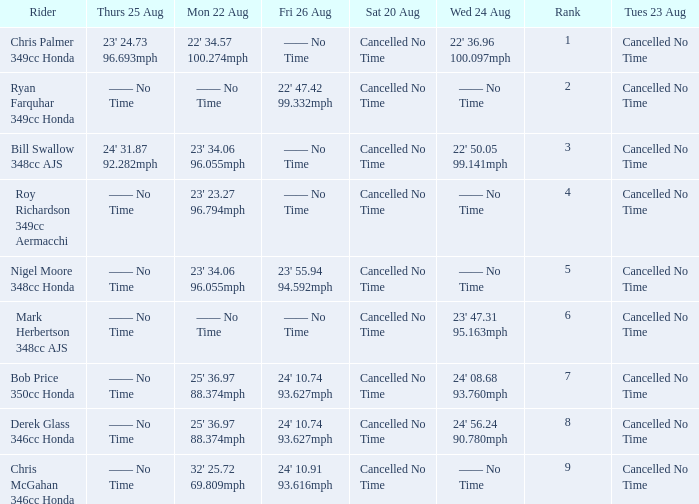What is every entry for Tuesday August 23 when Thursday August 25 is 24' 31.87 92.282mph? Cancelled No Time. 